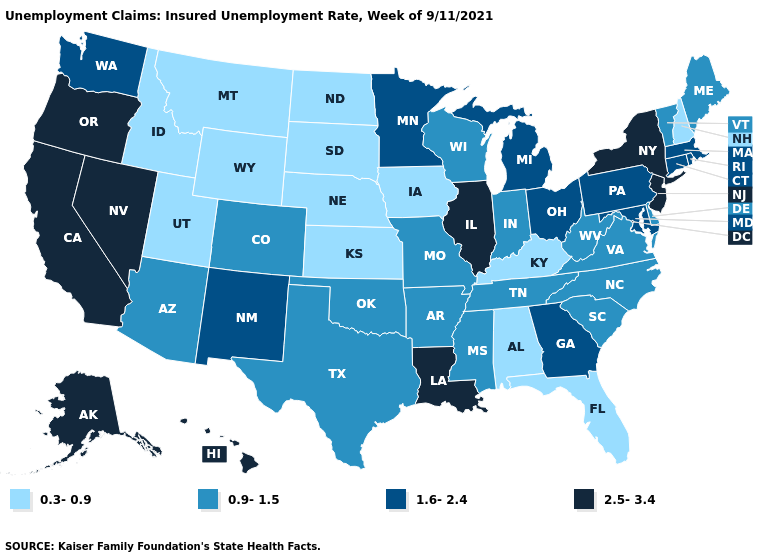Does Illinois have the highest value in the USA?
Quick response, please. Yes. What is the value of Minnesota?
Keep it brief. 1.6-2.4. Which states hav the highest value in the MidWest?
Give a very brief answer. Illinois. What is the value of Washington?
Keep it brief. 1.6-2.4. Does Utah have the highest value in the West?
Keep it brief. No. Among the states that border Kentucky , which have the lowest value?
Short answer required. Indiana, Missouri, Tennessee, Virginia, West Virginia. Does North Carolina have the highest value in the South?
Be succinct. No. What is the value of Delaware?
Give a very brief answer. 0.9-1.5. Is the legend a continuous bar?
Answer briefly. No. Is the legend a continuous bar?
Short answer required. No. What is the value of Arizona?
Write a very short answer. 0.9-1.5. Which states hav the highest value in the South?
Give a very brief answer. Louisiana. Among the states that border Nebraska , does Colorado have the highest value?
Write a very short answer. Yes. Does New Hampshire have the lowest value in the Northeast?
Give a very brief answer. Yes. Is the legend a continuous bar?
Quick response, please. No. 